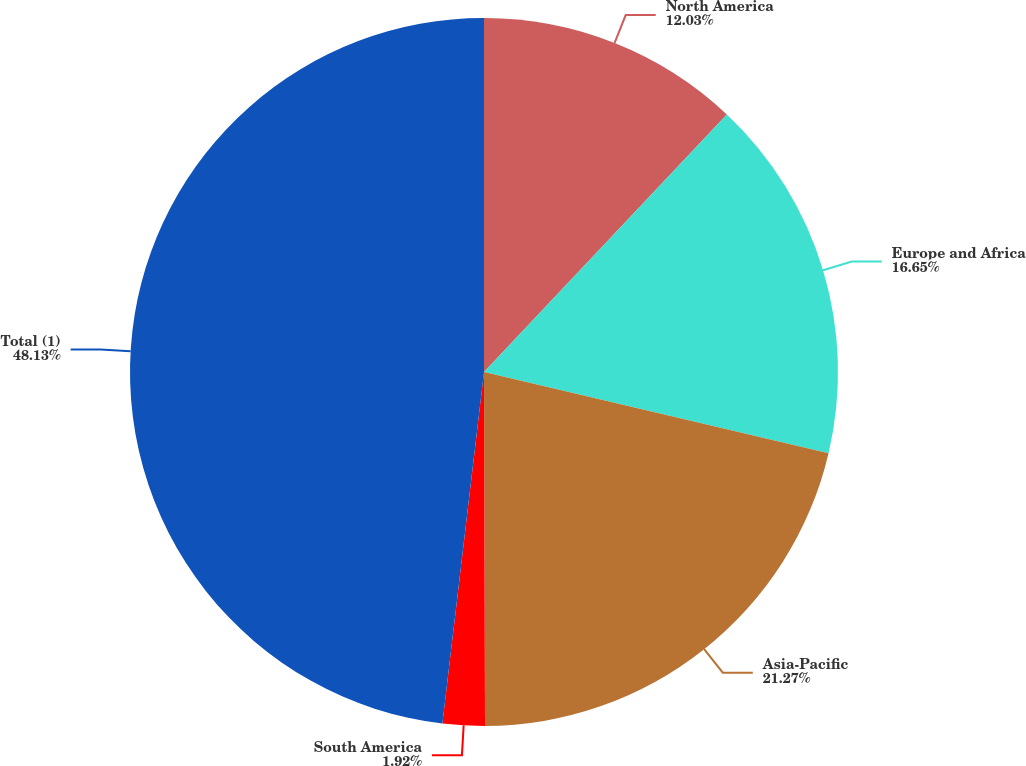Convert chart to OTSL. <chart><loc_0><loc_0><loc_500><loc_500><pie_chart><fcel>North America<fcel>Europe and Africa<fcel>Asia-Pacific<fcel>South America<fcel>Total (1)<nl><fcel>12.03%<fcel>16.65%<fcel>21.27%<fcel>1.92%<fcel>48.12%<nl></chart> 